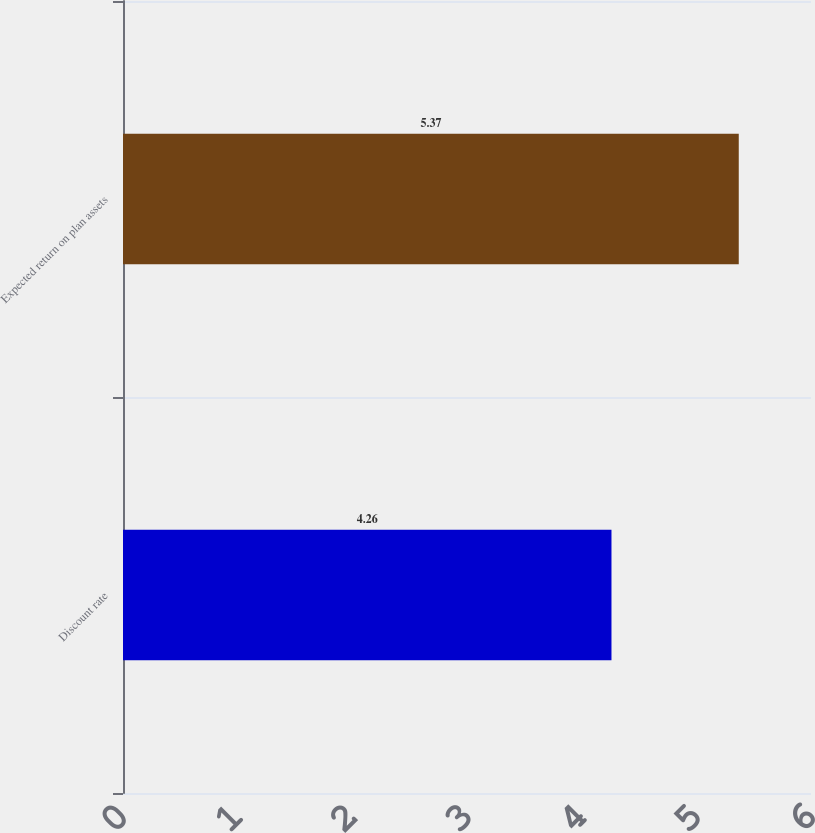Convert chart. <chart><loc_0><loc_0><loc_500><loc_500><bar_chart><fcel>Discount rate<fcel>Expected return on plan assets<nl><fcel>4.26<fcel>5.37<nl></chart> 